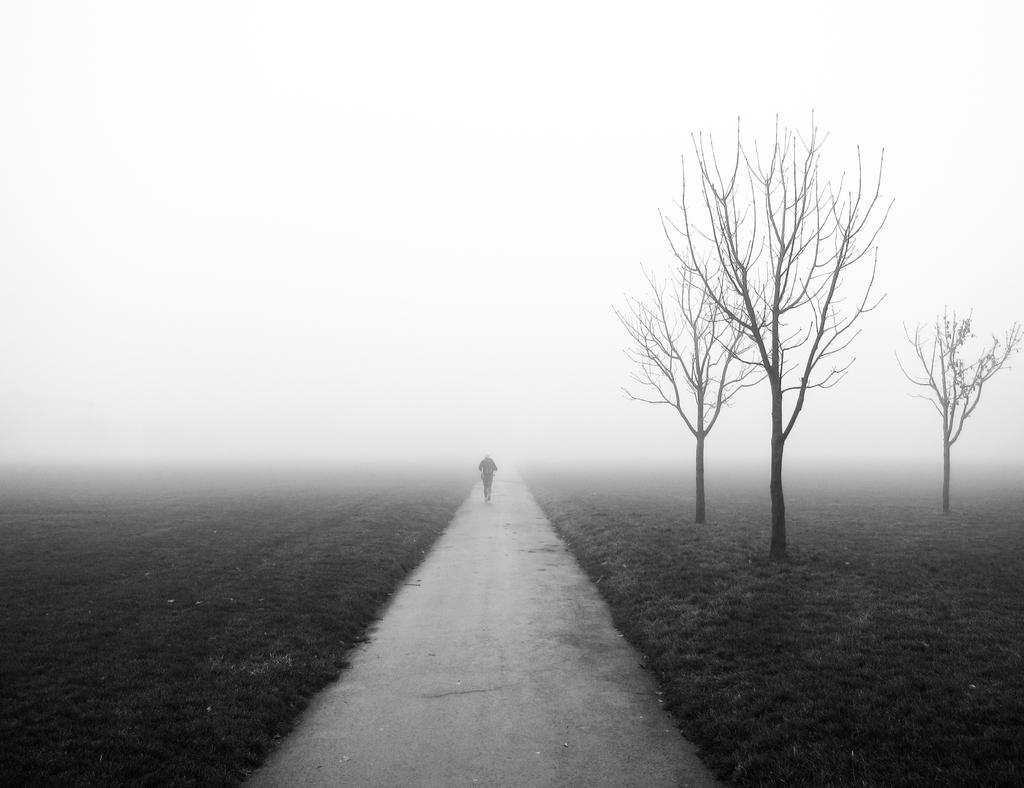Who is the main subject in the image? There is a man in the center of the image. What is the man doing in the image? The man is on the way, suggesting he is walking or traveling. What type of environment is visible in the image? There is greenery on both the right and left sides of the image, indicating a natural setting. Can you see the ocean in the image? No, the ocean is not present in the image; it features a man walking in a natural setting with greenery on both sides. What type of treatment is being administered to the man in the image? There is no treatment being administered to the man in the image; he is simply walking. 